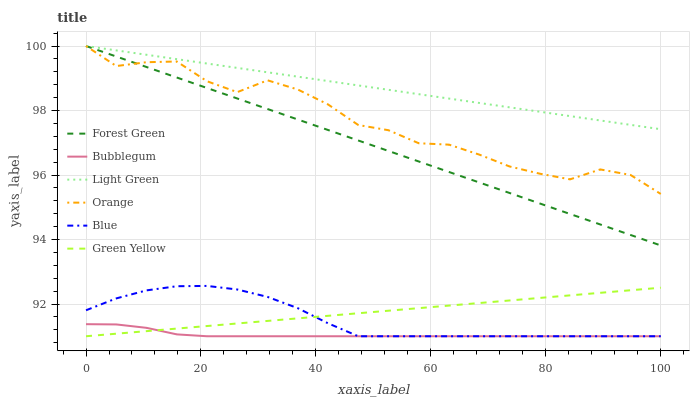Does Bubblegum have the minimum area under the curve?
Answer yes or no. Yes. Does Light Green have the maximum area under the curve?
Answer yes or no. Yes. Does Forest Green have the minimum area under the curve?
Answer yes or no. No. Does Forest Green have the maximum area under the curve?
Answer yes or no. No. Is Light Green the smoothest?
Answer yes or no. Yes. Is Orange the roughest?
Answer yes or no. Yes. Is Bubblegum the smoothest?
Answer yes or no. No. Is Bubblegum the roughest?
Answer yes or no. No. Does Blue have the lowest value?
Answer yes or no. Yes. Does Forest Green have the lowest value?
Answer yes or no. No. Does Orange have the highest value?
Answer yes or no. Yes. Does Bubblegum have the highest value?
Answer yes or no. No. Is Green Yellow less than Orange?
Answer yes or no. Yes. Is Forest Green greater than Blue?
Answer yes or no. Yes. Does Orange intersect Forest Green?
Answer yes or no. Yes. Is Orange less than Forest Green?
Answer yes or no. No. Is Orange greater than Forest Green?
Answer yes or no. No. Does Green Yellow intersect Orange?
Answer yes or no. No. 